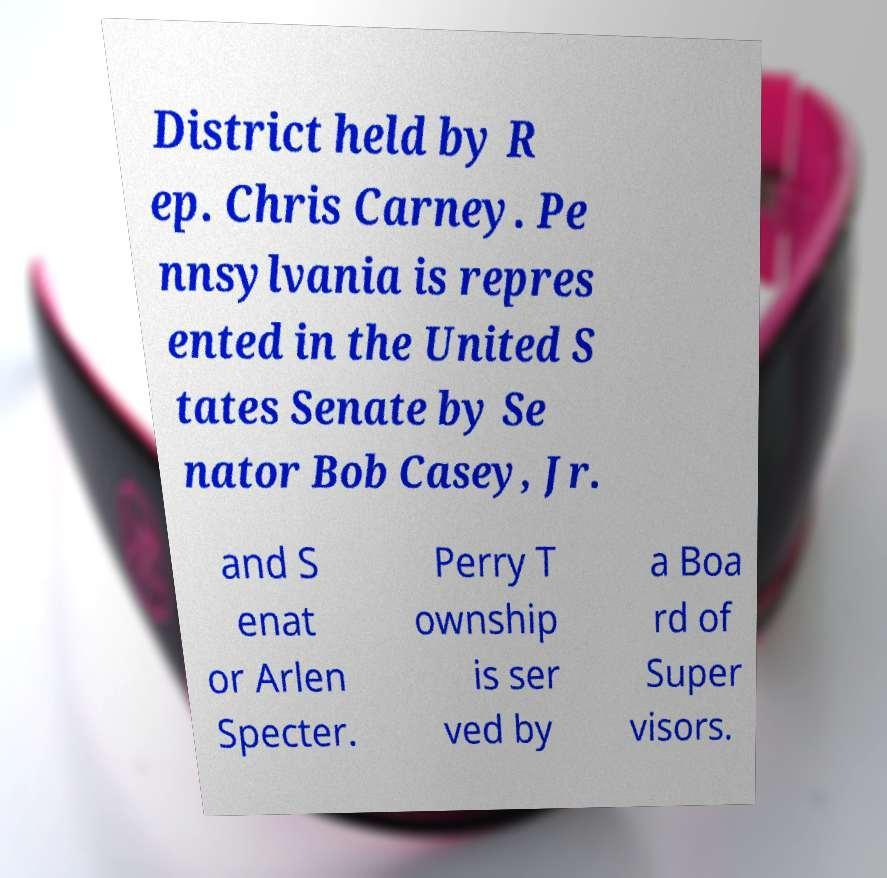Please identify and transcribe the text found in this image. District held by R ep. Chris Carney. Pe nnsylvania is repres ented in the United S tates Senate by Se nator Bob Casey, Jr. and S enat or Arlen Specter. Perry T ownship is ser ved by a Boa rd of Super visors. 